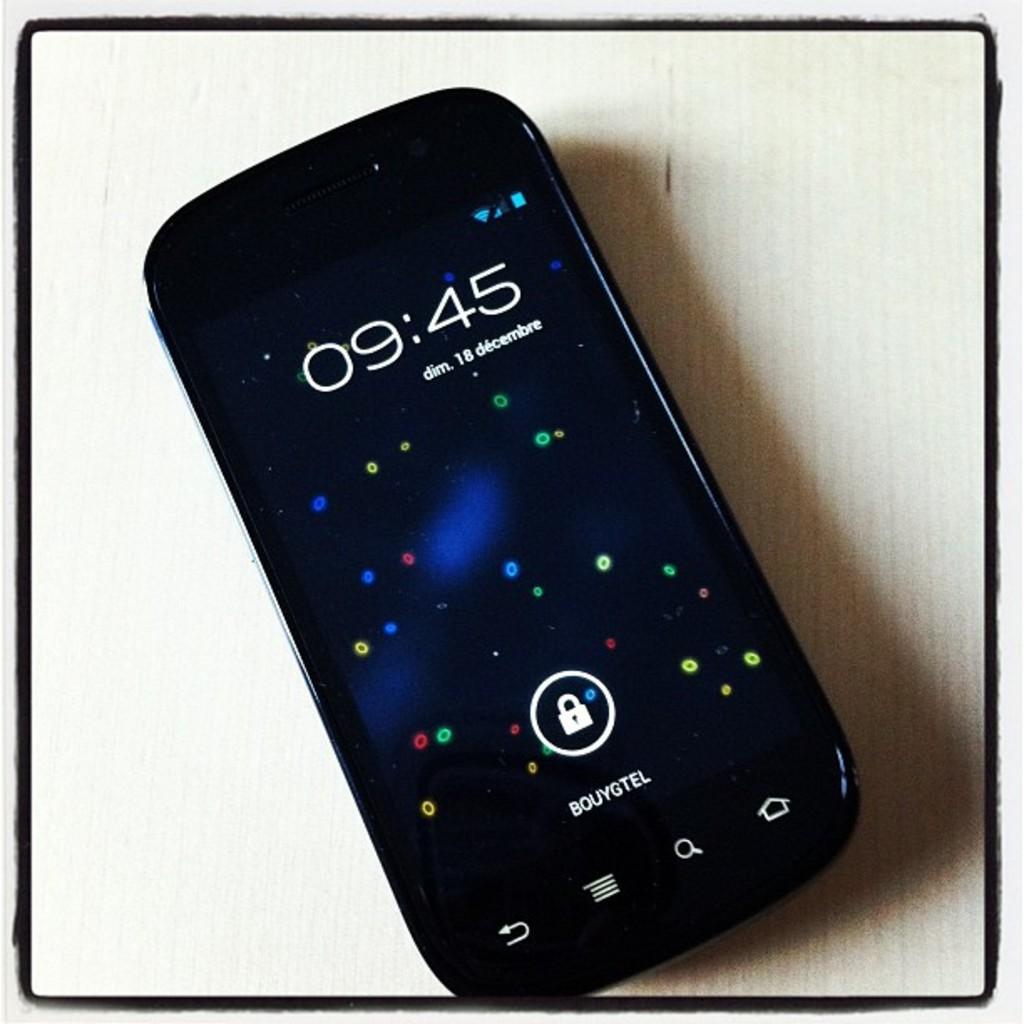What time is it?
Your answer should be very brief. 9:45. 